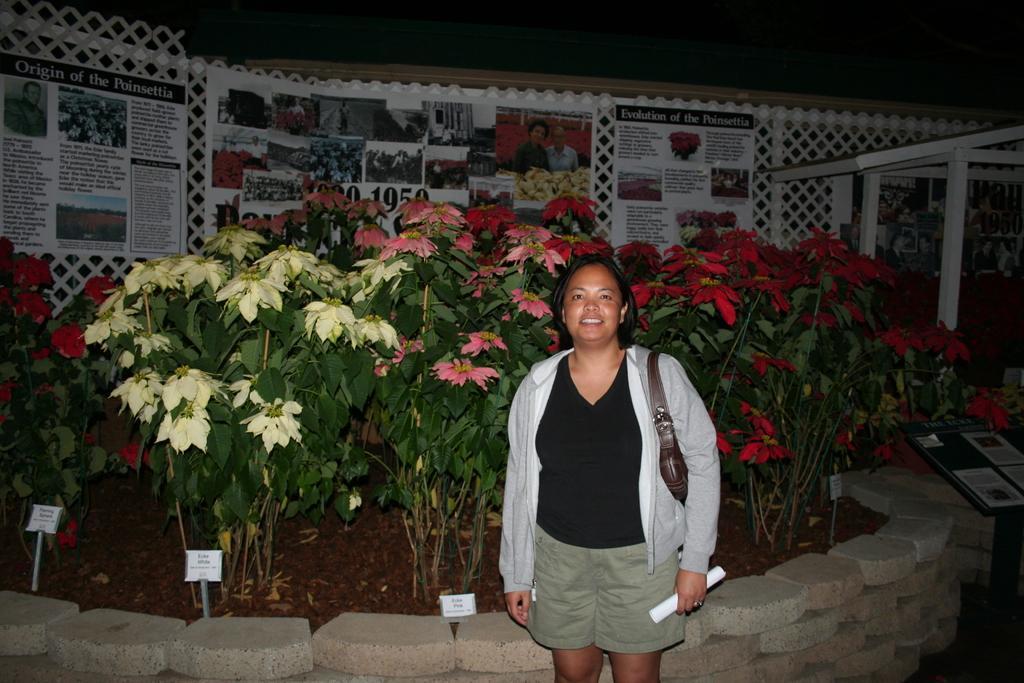In one or two sentences, can you explain what this image depicts? In this image we can see a person wearing a handbag and holding an object. There are few posters in the image. There is a board at the right side of the image. There are few rocks in the image. There are many flowers to the plants. We can see the dark background at the top of the image. There are few boards in the image. 